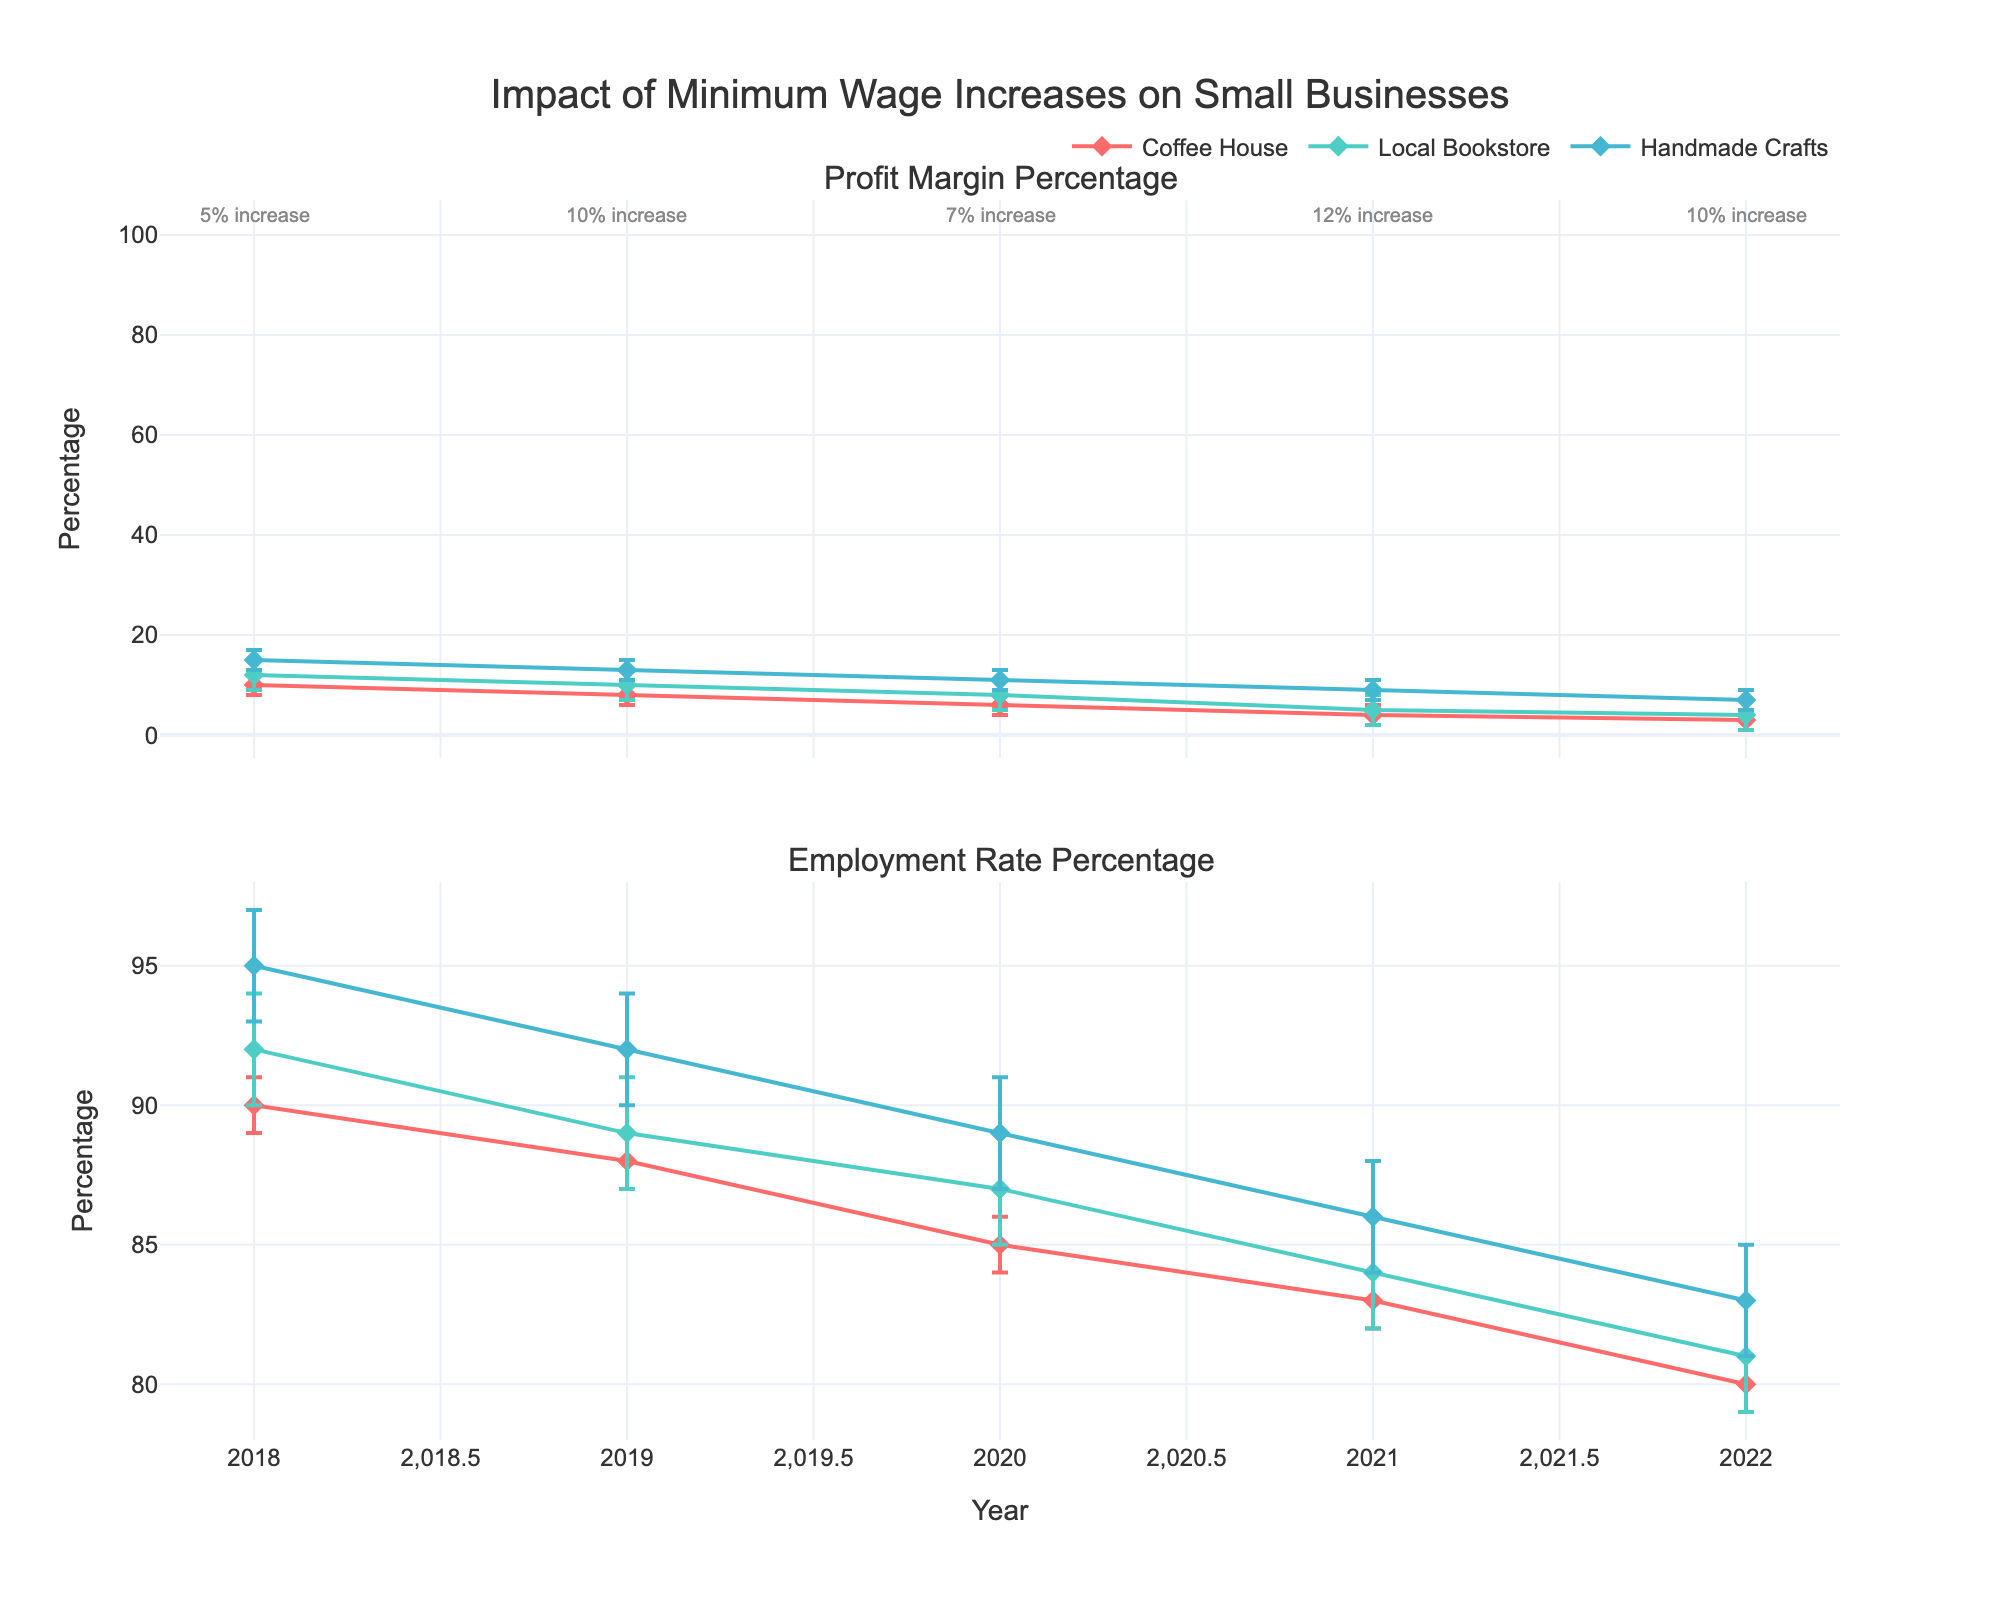How many businesses are being analyzed in the plot? Look at the legend, which lists the names of the businesses. The legend displays three different businesses.
Answer: 3 What is the title of the plot? The title is displayed at the top of the plot. It is "Impact of Minimum Wage Increases on Small Businesses."
Answer: Impact of Minimum Wage Increases on Small Businesses In which year did Handmade Crafts have the highest profit margin percentage? The profit margin percentage for Handmade Crafts is represented by the upper plot marked by diamond symbols. Compare the y-values across the years and identify that 2018 has the highest value.
Answer: 2018 Which business had the largest decline in profit margin percentage from 2018 to 2022? Compare the differences in the profit margin percentages from 2018 to 2022 for all three businesses by visually inspecting the length of the vertical lines. "Handmade Crafts" dropped from 15% to 7%, which is the largest decline.
Answer: Handmade Crafts How did the employment rate change from 2018 to 2022 for the Local Bookstore? Look at the employment rate percentage for the Local Bookstore in the second plot. In 2018, the rate was 92%, and in 2022, it was 81%, showing a decrease.
Answer: It decreased Which year had the highest minimum wage increase percentage? Identify the annotations near the top of the plot which show minimum wage increases for each year. The year 2021 shows a 12% increase, which is the highest.
Answer: 2021 Which business experienced the smallest decrease in employment rate from 2018 to 2022? Inspect the second plot and compare the employment rate percentages across the years for each business. Calculate the differences: Coffee House (90% to 80% = 10%), Local Bookstore (92% to 81% = 11%), Handmade Crafts (95% to 83% = 12%). The "Coffee House" shows the smallest decrease.
Answer: Coffee House What is the average profit margin percentage for Coffee House over the years? Find the profit margin percentages for Coffee House across the years: 10, 8, 6, 4, and 3. Sum these values and divide by the number of years: 10 + 8 + 6 + 4 + 3 = 31, and 31 / 5 = 6.2.
Answer: 6.2 What is the difference in employment rates between Coffee House and Handmade Crafts in 2020? Look at the employment rates for 2020: Coffee House (85%), Handmade Crafts (89%). Subtract Coffee House's rate from Handmade Crafts' rate: 89% - 85% = 4%.
Answer: 4% 